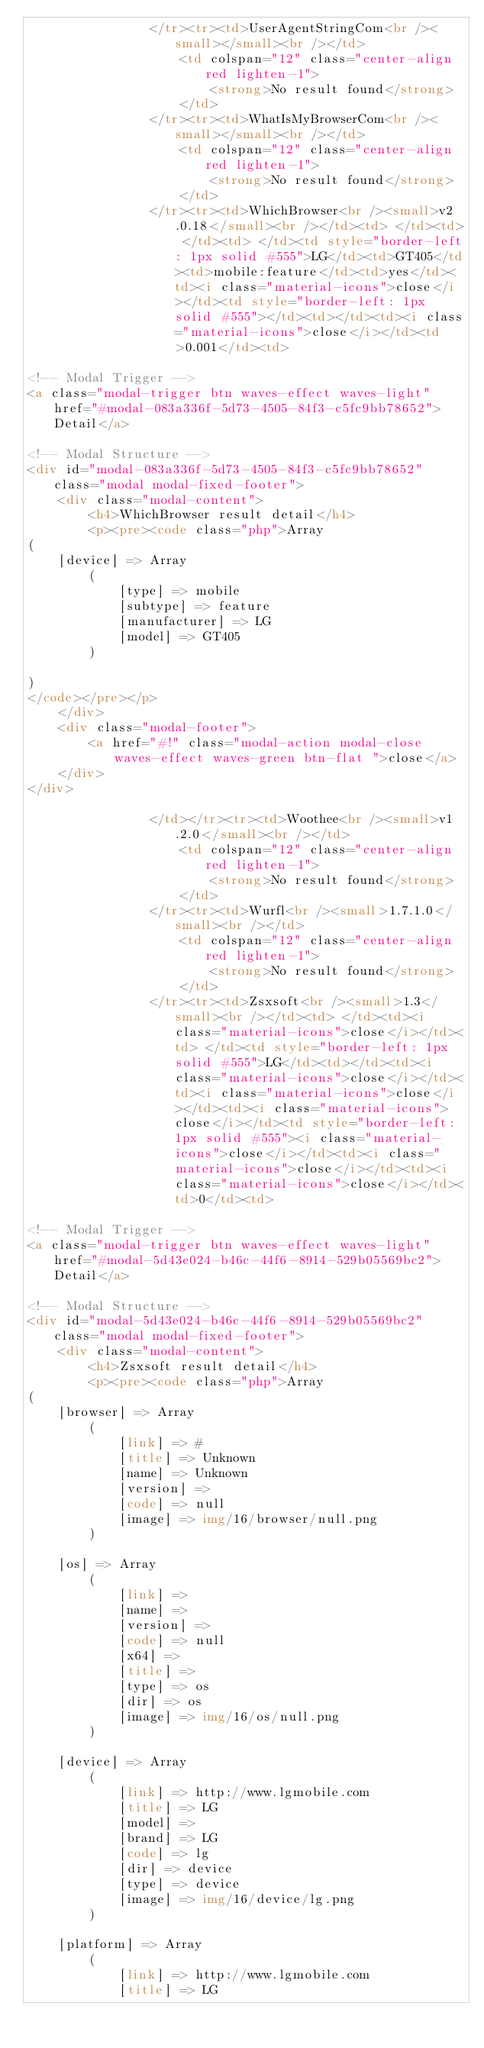<code> <loc_0><loc_0><loc_500><loc_500><_HTML_>                </tr><tr><td>UserAgentStringCom<br /><small></small><br /></td>
                    <td colspan="12" class="center-align red lighten-1">
                        <strong>No result found</strong>
                    </td>
                </tr><tr><td>WhatIsMyBrowserCom<br /><small></small><br /></td>
                    <td colspan="12" class="center-align red lighten-1">
                        <strong>No result found</strong>
                    </td>
                </tr><tr><td>WhichBrowser<br /><small>v2.0.18</small><br /></td><td> </td><td> </td><td> </td><td style="border-left: 1px solid #555">LG</td><td>GT405</td><td>mobile:feature</td><td>yes</td><td><i class="material-icons">close</i></td><td style="border-left: 1px solid #555"></td><td></td><td><i class="material-icons">close</i></td><td>0.001</td><td>
        
<!-- Modal Trigger -->
<a class="modal-trigger btn waves-effect waves-light" href="#modal-083a336f-5d73-4505-84f3-c5fc9bb78652">Detail</a>
        
<!-- Modal Structure -->
<div id="modal-083a336f-5d73-4505-84f3-c5fc9bb78652" class="modal modal-fixed-footer">
    <div class="modal-content">
        <h4>WhichBrowser result detail</h4>
        <p><pre><code class="php">Array
(
    [device] => Array
        (
            [type] => mobile
            [subtype] => feature
            [manufacturer] => LG
            [model] => GT405
        )

)
</code></pre></p>
    </div>
    <div class="modal-footer">
        <a href="#!" class="modal-action modal-close waves-effect waves-green btn-flat ">close</a>
    </div>
</div>
        
                </td></tr><tr><td>Woothee<br /><small>v1.2.0</small><br /></td>
                    <td colspan="12" class="center-align red lighten-1">
                        <strong>No result found</strong>
                    </td>
                </tr><tr><td>Wurfl<br /><small>1.7.1.0</small><br /></td>
                    <td colspan="12" class="center-align red lighten-1">
                        <strong>No result found</strong>
                    </td>
                </tr><tr><td>Zsxsoft<br /><small>1.3</small><br /></td><td> </td><td><i class="material-icons">close</i></td><td> </td><td style="border-left: 1px solid #555">LG</td><td></td><td><i class="material-icons">close</i></td><td><i class="material-icons">close</i></td><td><i class="material-icons">close</i></td><td style="border-left: 1px solid #555"><i class="material-icons">close</i></td><td><i class="material-icons">close</i></td><td><i class="material-icons">close</i></td><td>0</td><td>
        
<!-- Modal Trigger -->
<a class="modal-trigger btn waves-effect waves-light" href="#modal-5d43e024-b46c-44f6-8914-529b05569bc2">Detail</a>
        
<!-- Modal Structure -->
<div id="modal-5d43e024-b46c-44f6-8914-529b05569bc2" class="modal modal-fixed-footer">
    <div class="modal-content">
        <h4>Zsxsoft result detail</h4>
        <p><pre><code class="php">Array
(
    [browser] => Array
        (
            [link] => #
            [title] => Unknown
            [name] => Unknown
            [version] => 
            [code] => null
            [image] => img/16/browser/null.png
        )

    [os] => Array
        (
            [link] => 
            [name] => 
            [version] => 
            [code] => null
            [x64] => 
            [title] => 
            [type] => os
            [dir] => os
            [image] => img/16/os/null.png
        )

    [device] => Array
        (
            [link] => http://www.lgmobile.com
            [title] => LG
            [model] => 
            [brand] => LG
            [code] => lg
            [dir] => device
            [type] => device
            [image] => img/16/device/lg.png
        )

    [platform] => Array
        (
            [link] => http://www.lgmobile.com
            [title] => LG</code> 